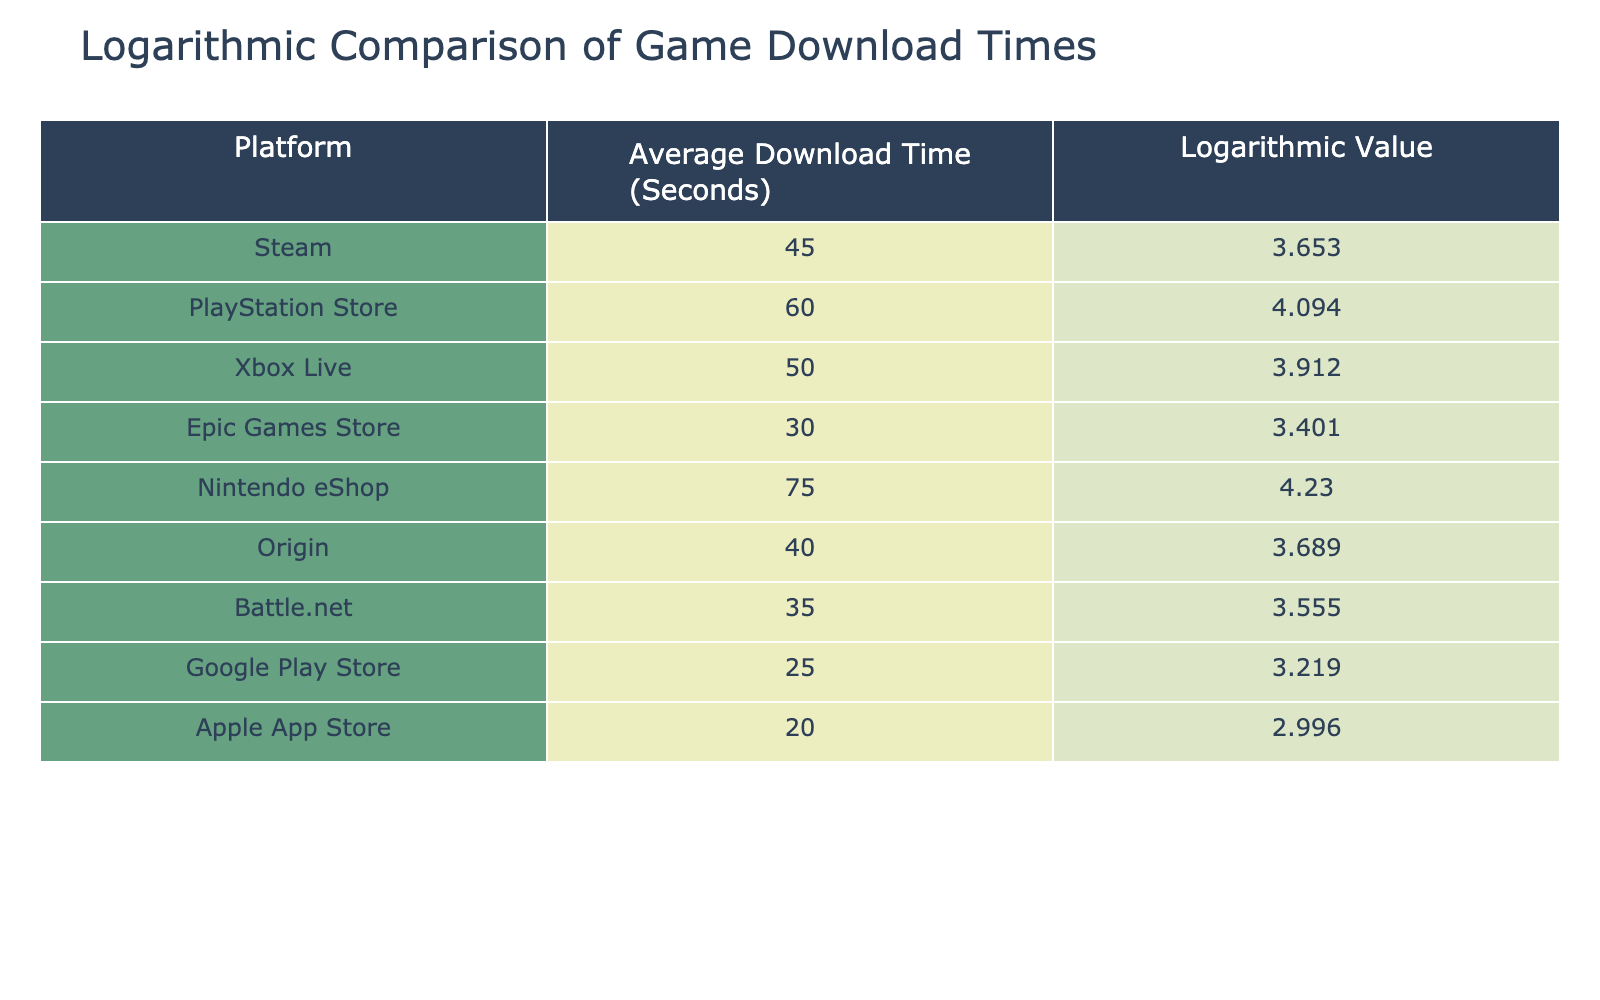What is the average download time for the Xbox Live platform? From the table, the average download time for Xbox Live is listed as 50 seconds.
Answer: 50 seconds Which platform has the shortest average download time? By looking at the "Average Download Time (Seconds)" column, Google Play Store has the shortest time at 25 seconds.
Answer: Google Play Store How much longer on average does it take to download from the Nintendo eShop compared to the Apple App Store? The average download time for the Nintendo eShop is 75 seconds, and for the Apple App Store, it is 20 seconds. The difference is 75 - 20 = 55 seconds.
Answer: 55 seconds Is the logarithmic value for the Steam platform higher than the logarithmic value for the Epic Games Store? The logarithmic value for Steam is 3.653, while for Epic Games Store, it is 3.401. Since 3.653 is greater than 3.401, the statement is true.
Answer: Yes What is the average logarithmic value of the platforms listed in the table? To calculate the average, we sum all logarithmic values: 3.653 + 4.094 + 3.912 + 3.401 + 4.230 + 3.689 + 3.555 + 3.219 + 2.996 = 33.75, and divide by the number of platforms, which is 9: 33.75 / 9 ≈ 3.75.
Answer: Approximately 3.75 Which platform shows the highest logarithmic value and what is that value? By examining the logarithmic values in the table, the Nintendo eShop has the highest value at 4.230.
Answer: 4.230 How does the average download time of the PlayStation Store compare to the average of Steam and Origin combined? The average download time for the PlayStation Store is 60 seconds. The average of Steam (45 seconds) and Origin (40 seconds) is (45 + 40) / 2 = 42.5 seconds. Comparing 60 seconds with 42.5 seconds, 60 is greater than 42.5.
Answer: 60 seconds is greater Is there any platform that has an average download time equal to or less than 30 seconds? The table lists Epic Games Store with an average of 30 seconds and Google Play Store with 25 seconds, both of which are equal to or less than 30 seconds. Thus, the answer is true.
Answer: Yes 